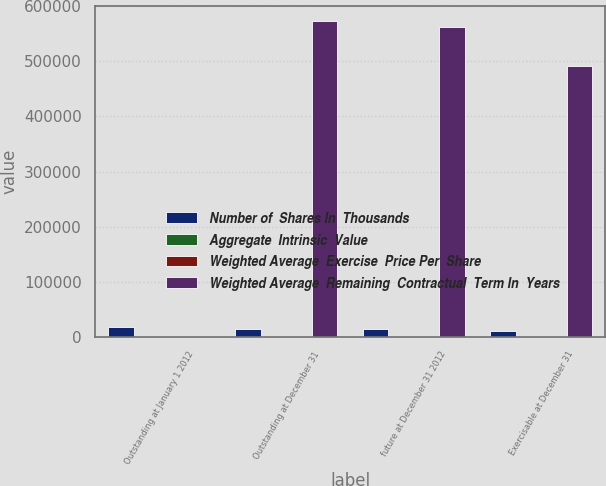Convert chart. <chart><loc_0><loc_0><loc_500><loc_500><stacked_bar_chart><ecel><fcel>Outstanding at January 1 2012<fcel>Outstanding at December 31<fcel>future at December 31 2012<fcel>Exercisable at December 31<nl><fcel>Number of  Shares In  Thousands<fcel>18569<fcel>14000<fcel>13542<fcel>11043<nl><fcel>Aggregate  Intrinsic  Value<fcel>8.57<fcel>12.12<fcel>11.41<fcel>8.29<nl><fcel>Weighted Average  Exercise  Price Per  Share<fcel>4.1<fcel>4.1<fcel>4<fcel>3.3<nl><fcel>Weighted Average  Remaining  Contractual  Term In  Years<fcel>12.12<fcel>572530<fcel>562816<fcel>492022<nl></chart> 